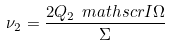Convert formula to latex. <formula><loc_0><loc_0><loc_500><loc_500>\nu _ { 2 } = \frac { 2 Q _ { 2 } \ m a t h s c r { I } \Omega } { \Sigma }</formula> 